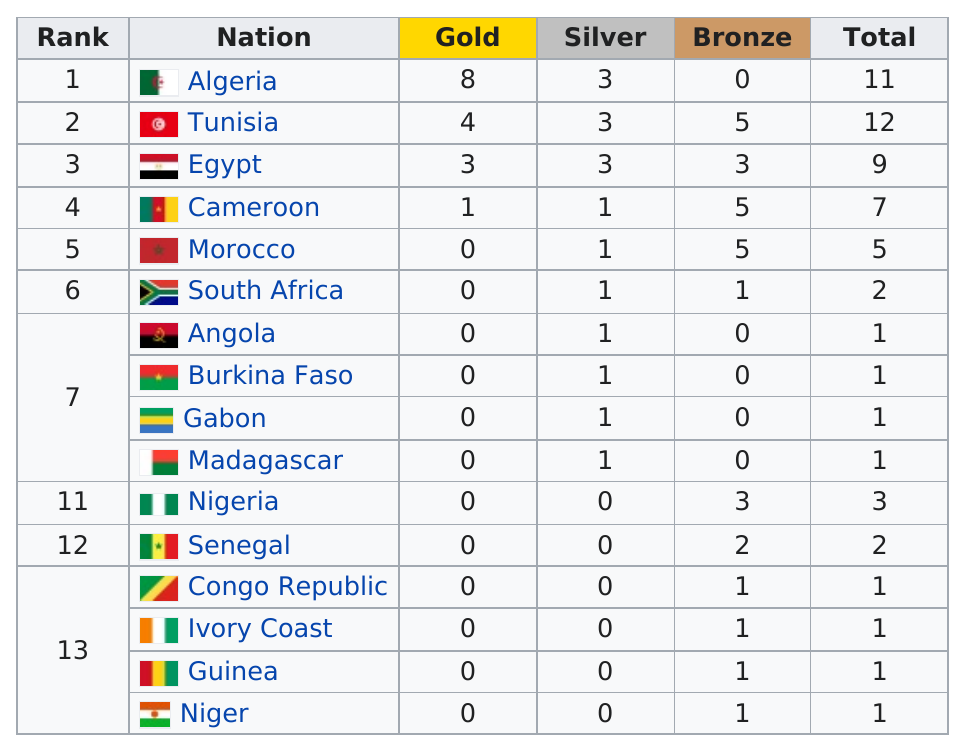Highlight a few significant elements in this photo. There are eleven countries that have less total metals than Morocco. Egypt earned a total of three silver medals in the competition. Out of the countries that won at least three gold medals, how many countries scored at least three gold medals? There were a total of 3 countries that earned three silver medals. Algeria, Tunisia, and Egypt are the countries that have at least nine metals. 